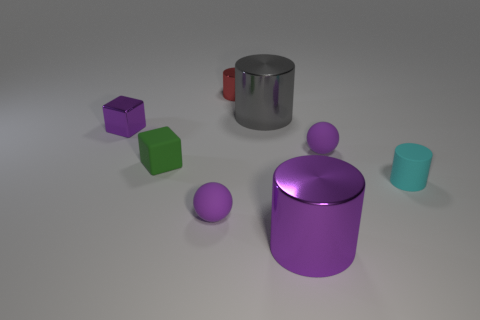Are there any small rubber things that have the same color as the metal cube?
Provide a short and direct response. Yes. There is a metallic block; is its color the same as the large metal cylinder in front of the small cyan matte cylinder?
Ensure brevity in your answer.  Yes. Is the shape of the purple shiny thing that is in front of the tiny cyan cylinder the same as  the gray thing?
Your response must be concise. Yes. There is a large cylinder in front of the small shiny block; what is its material?
Keep it short and to the point. Metal. What shape is the small purple thing that is to the right of the purple shiny block and to the left of the small metallic cylinder?
Provide a short and direct response. Sphere. What is the material of the small purple block?
Your response must be concise. Metal. What number of cubes are gray objects or small purple rubber objects?
Offer a very short reply. 0. Does the small green thing have the same material as the tiny red thing?
Your answer should be very brief. No. There is a purple thing that is the same shape as the green object; what is its size?
Provide a succinct answer. Small. There is a cylinder that is both to the left of the cyan object and in front of the big gray metallic thing; what is it made of?
Provide a short and direct response. Metal. 